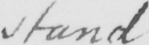What does this handwritten line say? stand 